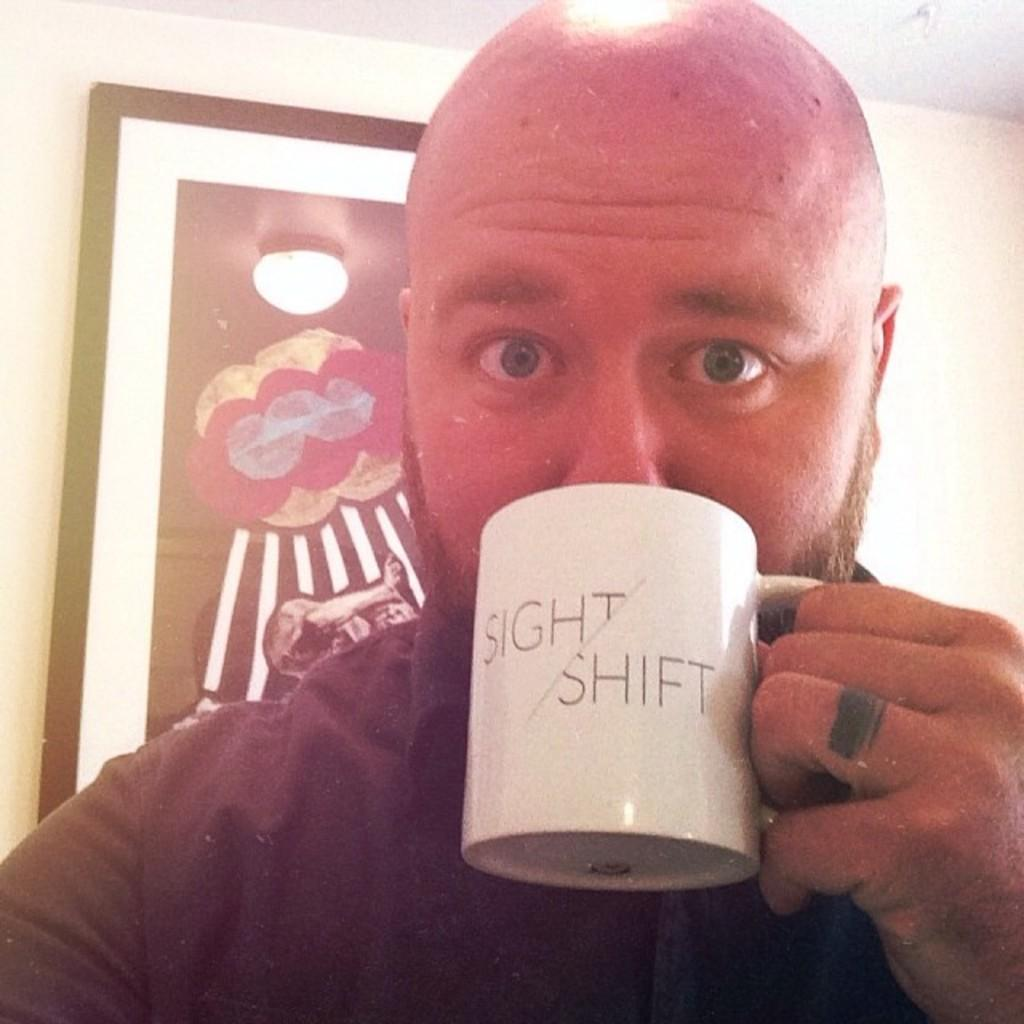<image>
Write a terse but informative summary of the picture. a bald man drinking from a mug with the words Sight Shift 